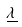<formula> <loc_0><loc_0><loc_500><loc_500>\underline { \lambda }</formula> 